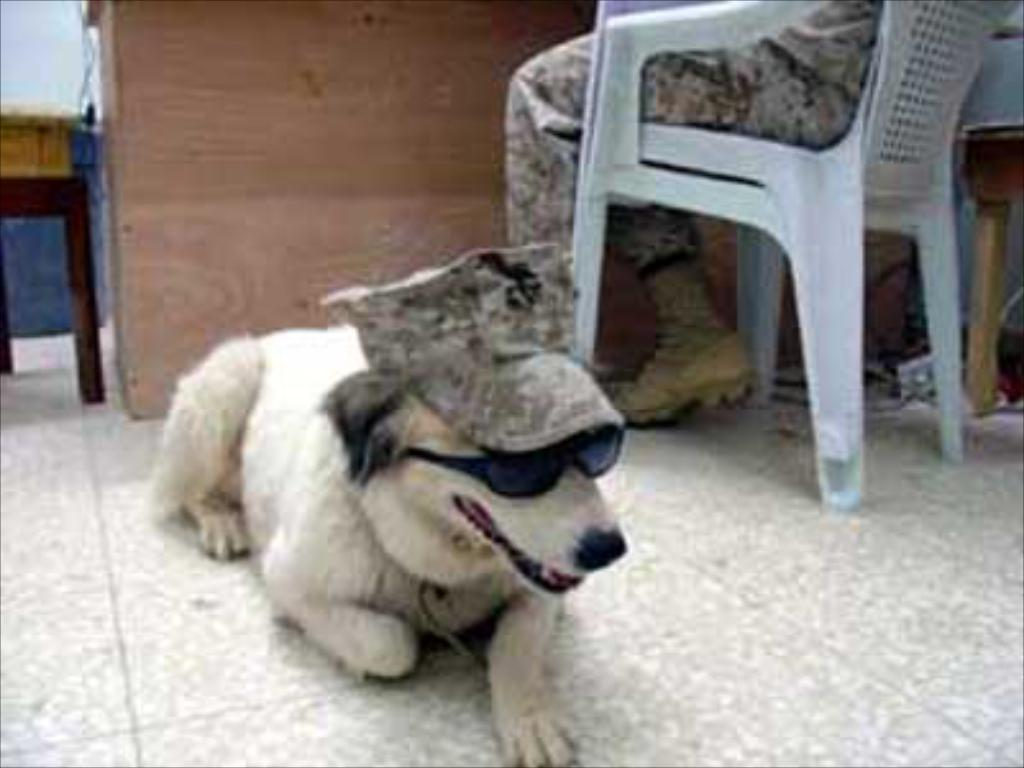What animal can be seen on the floor in the image? There is a dog on the floor in the image. What is the person in the background doing? The person is sitting on a chair in the background. What type of furniture is present in the image? There is a cupboard and a table in the image. What is the background of the image made up of? There is a wall in the image. Is the banana hot in the image? There is no banana present in the image, so it cannot be determined if it is hot or not. 